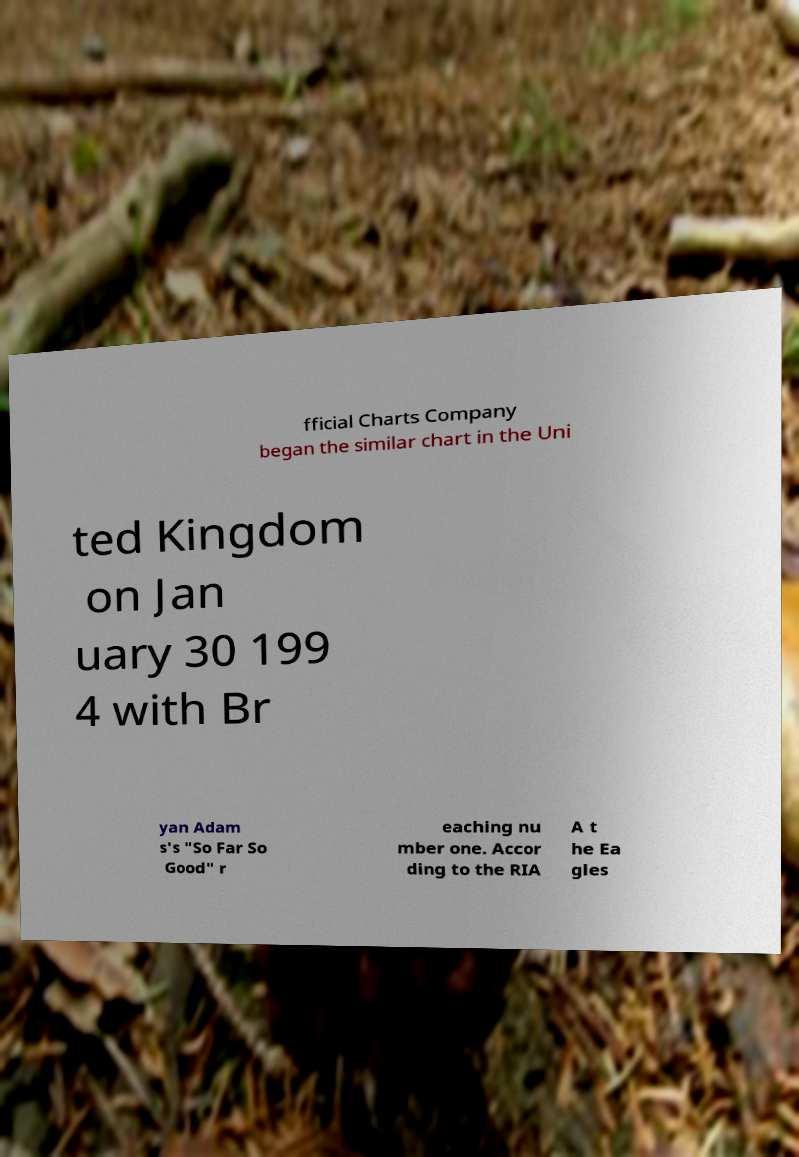There's text embedded in this image that I need extracted. Can you transcribe it verbatim? fficial Charts Company began the similar chart in the Uni ted Kingdom on Jan uary 30 199 4 with Br yan Adam s's "So Far So Good" r eaching nu mber one. Accor ding to the RIA A t he Ea gles 